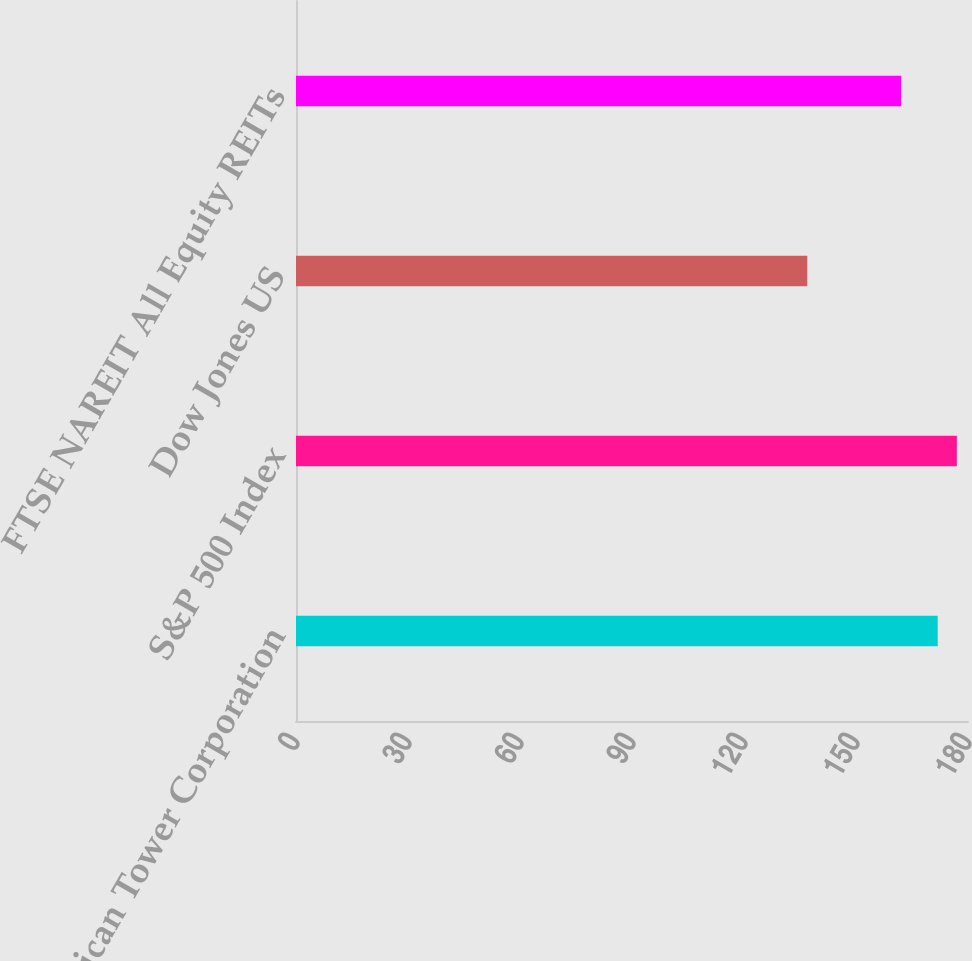Convert chart to OTSL. <chart><loc_0><loc_0><loc_500><loc_500><bar_chart><fcel>American Tower Corporation<fcel>S&P 500 Index<fcel>Dow Jones US<fcel>FTSE NAREIT All Equity REITs<nl><fcel>171.88<fcel>177.01<fcel>136.95<fcel>162.08<nl></chart> 